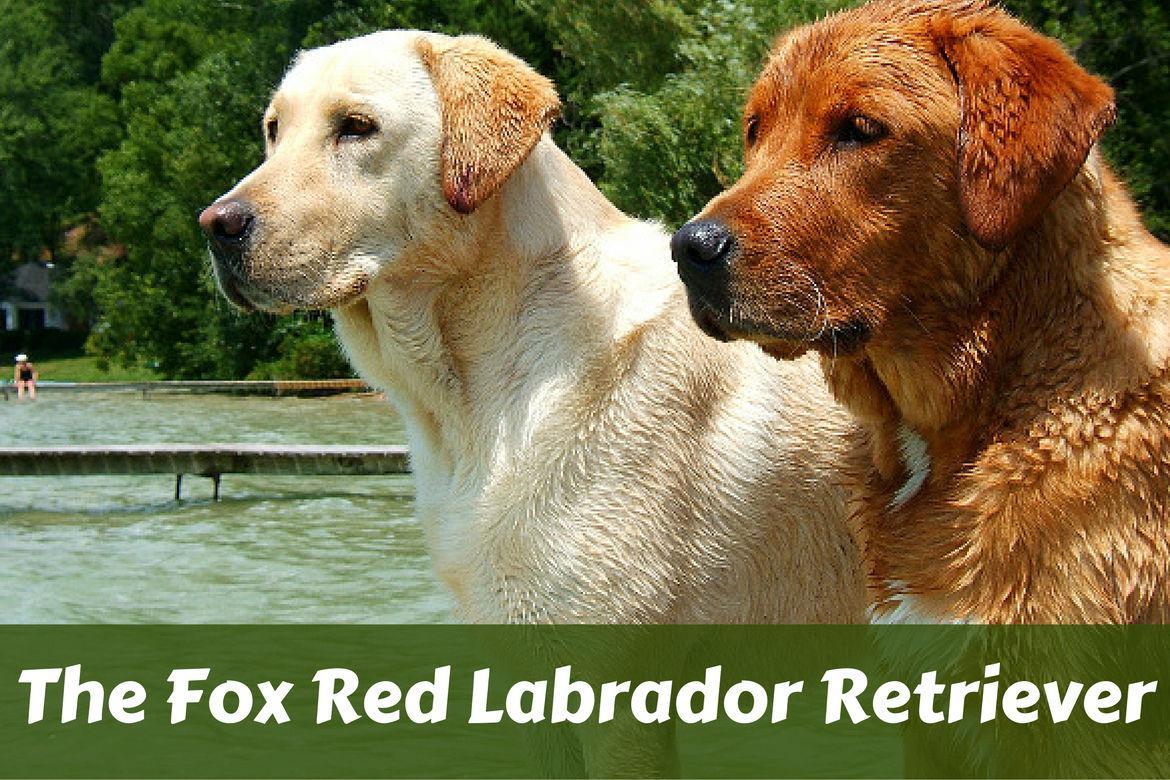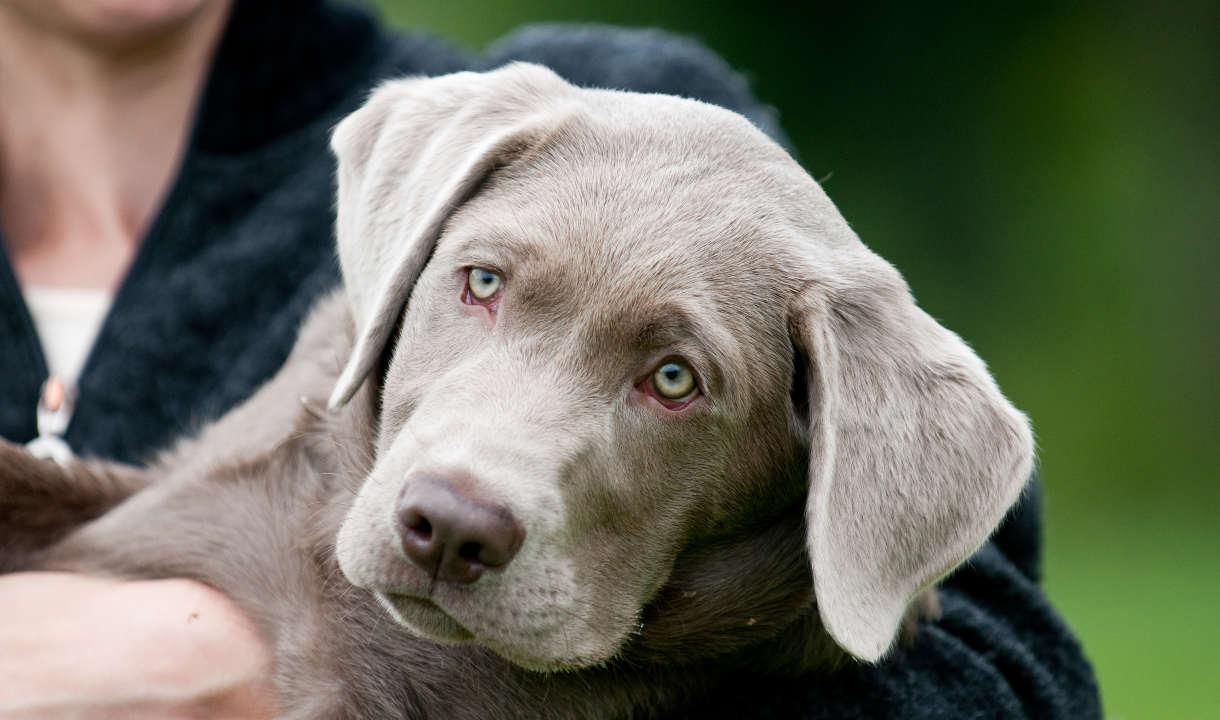The first image is the image on the left, the second image is the image on the right. Evaluate the accuracy of this statement regarding the images: "Three dogs are sitting on the ground in the image on the left.". Is it true? Answer yes or no. No. The first image is the image on the left, the second image is the image on the right. For the images shown, is this caption "Each image shows at least three labrador retriever dogs sitting upright in a horizontal row." true? Answer yes or no. No. 